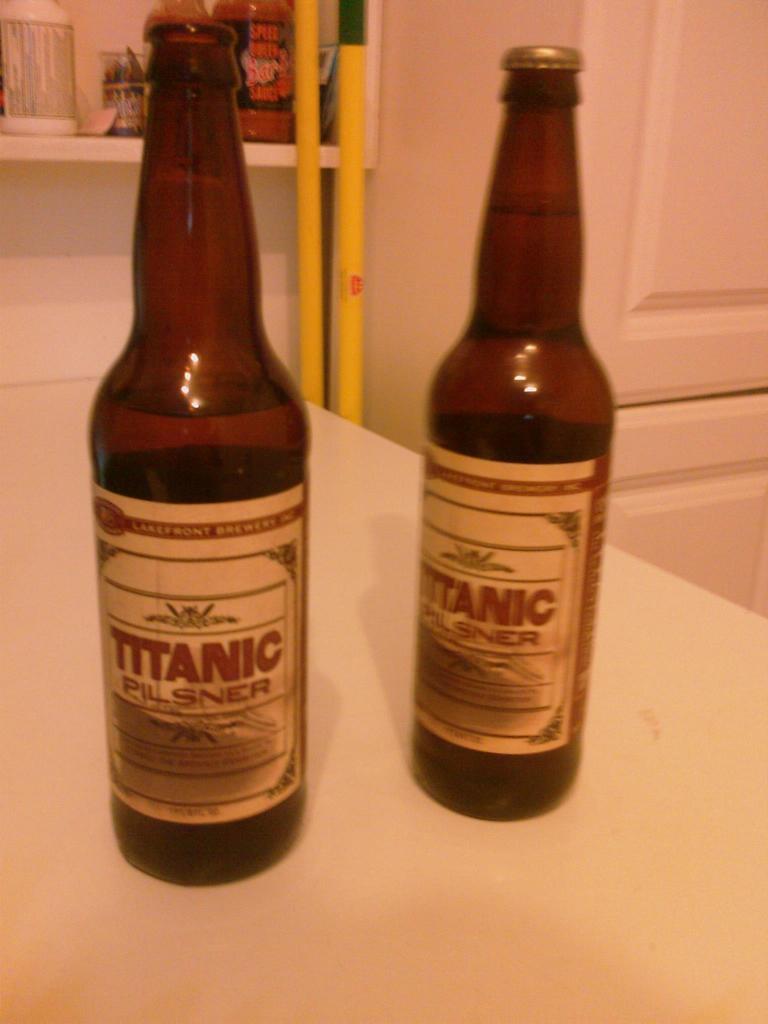What is the name of the beer?
Keep it short and to the point. Titanic. What brand is this beer?
Ensure brevity in your answer.  Titanic. 